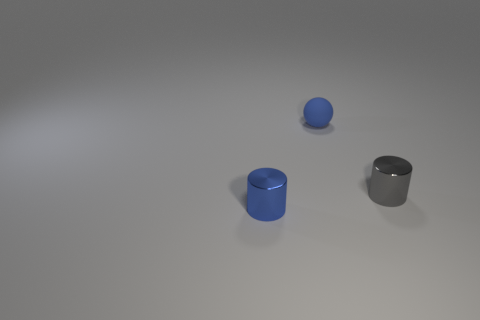Add 1 purple rubber cubes. How many objects exist? 4 Subtract all cylinders. How many objects are left? 1 Subtract all red balls. How many blue cylinders are left? 1 Subtract all gray rubber balls. Subtract all small matte spheres. How many objects are left? 2 Add 3 blue matte spheres. How many blue matte spheres are left? 4 Add 2 small red cylinders. How many small red cylinders exist? 2 Subtract 1 gray cylinders. How many objects are left? 2 Subtract 1 cylinders. How many cylinders are left? 1 Subtract all purple cylinders. Subtract all blue spheres. How many cylinders are left? 2 